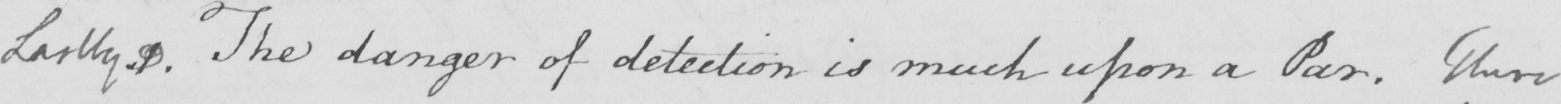What is written in this line of handwriting? Lastly 1 . The danger of detection is much upon a Par . There 